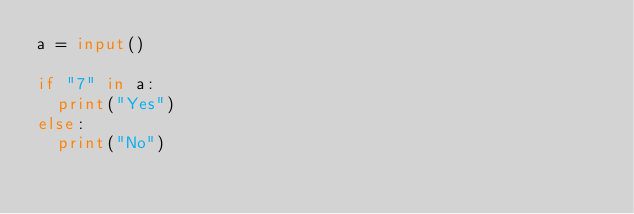Convert code to text. <code><loc_0><loc_0><loc_500><loc_500><_Python_>a = input()

if "7" in a:
  print("Yes")
else:
  print("No")        </code> 